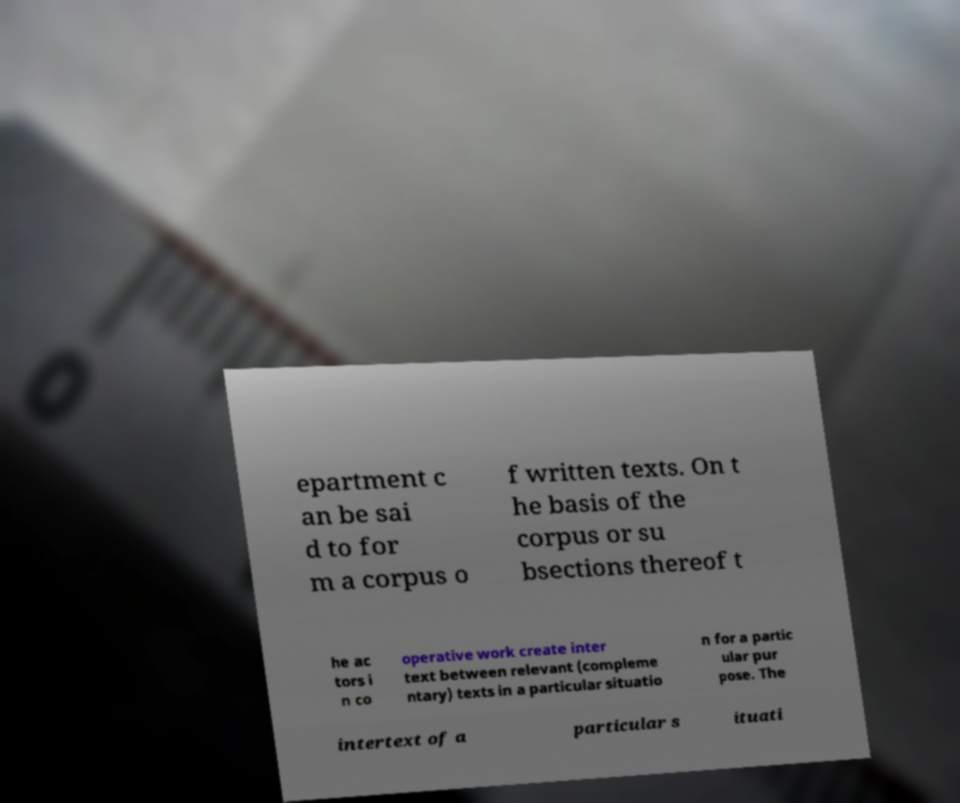Can you accurately transcribe the text from the provided image for me? epartment c an be sai d to for m a corpus o f written texts. On t he basis of the corpus or su bsections thereof t he ac tors i n co operative work create inter text between relevant (compleme ntary) texts in a particular situatio n for a partic ular pur pose. The intertext of a particular s ituati 